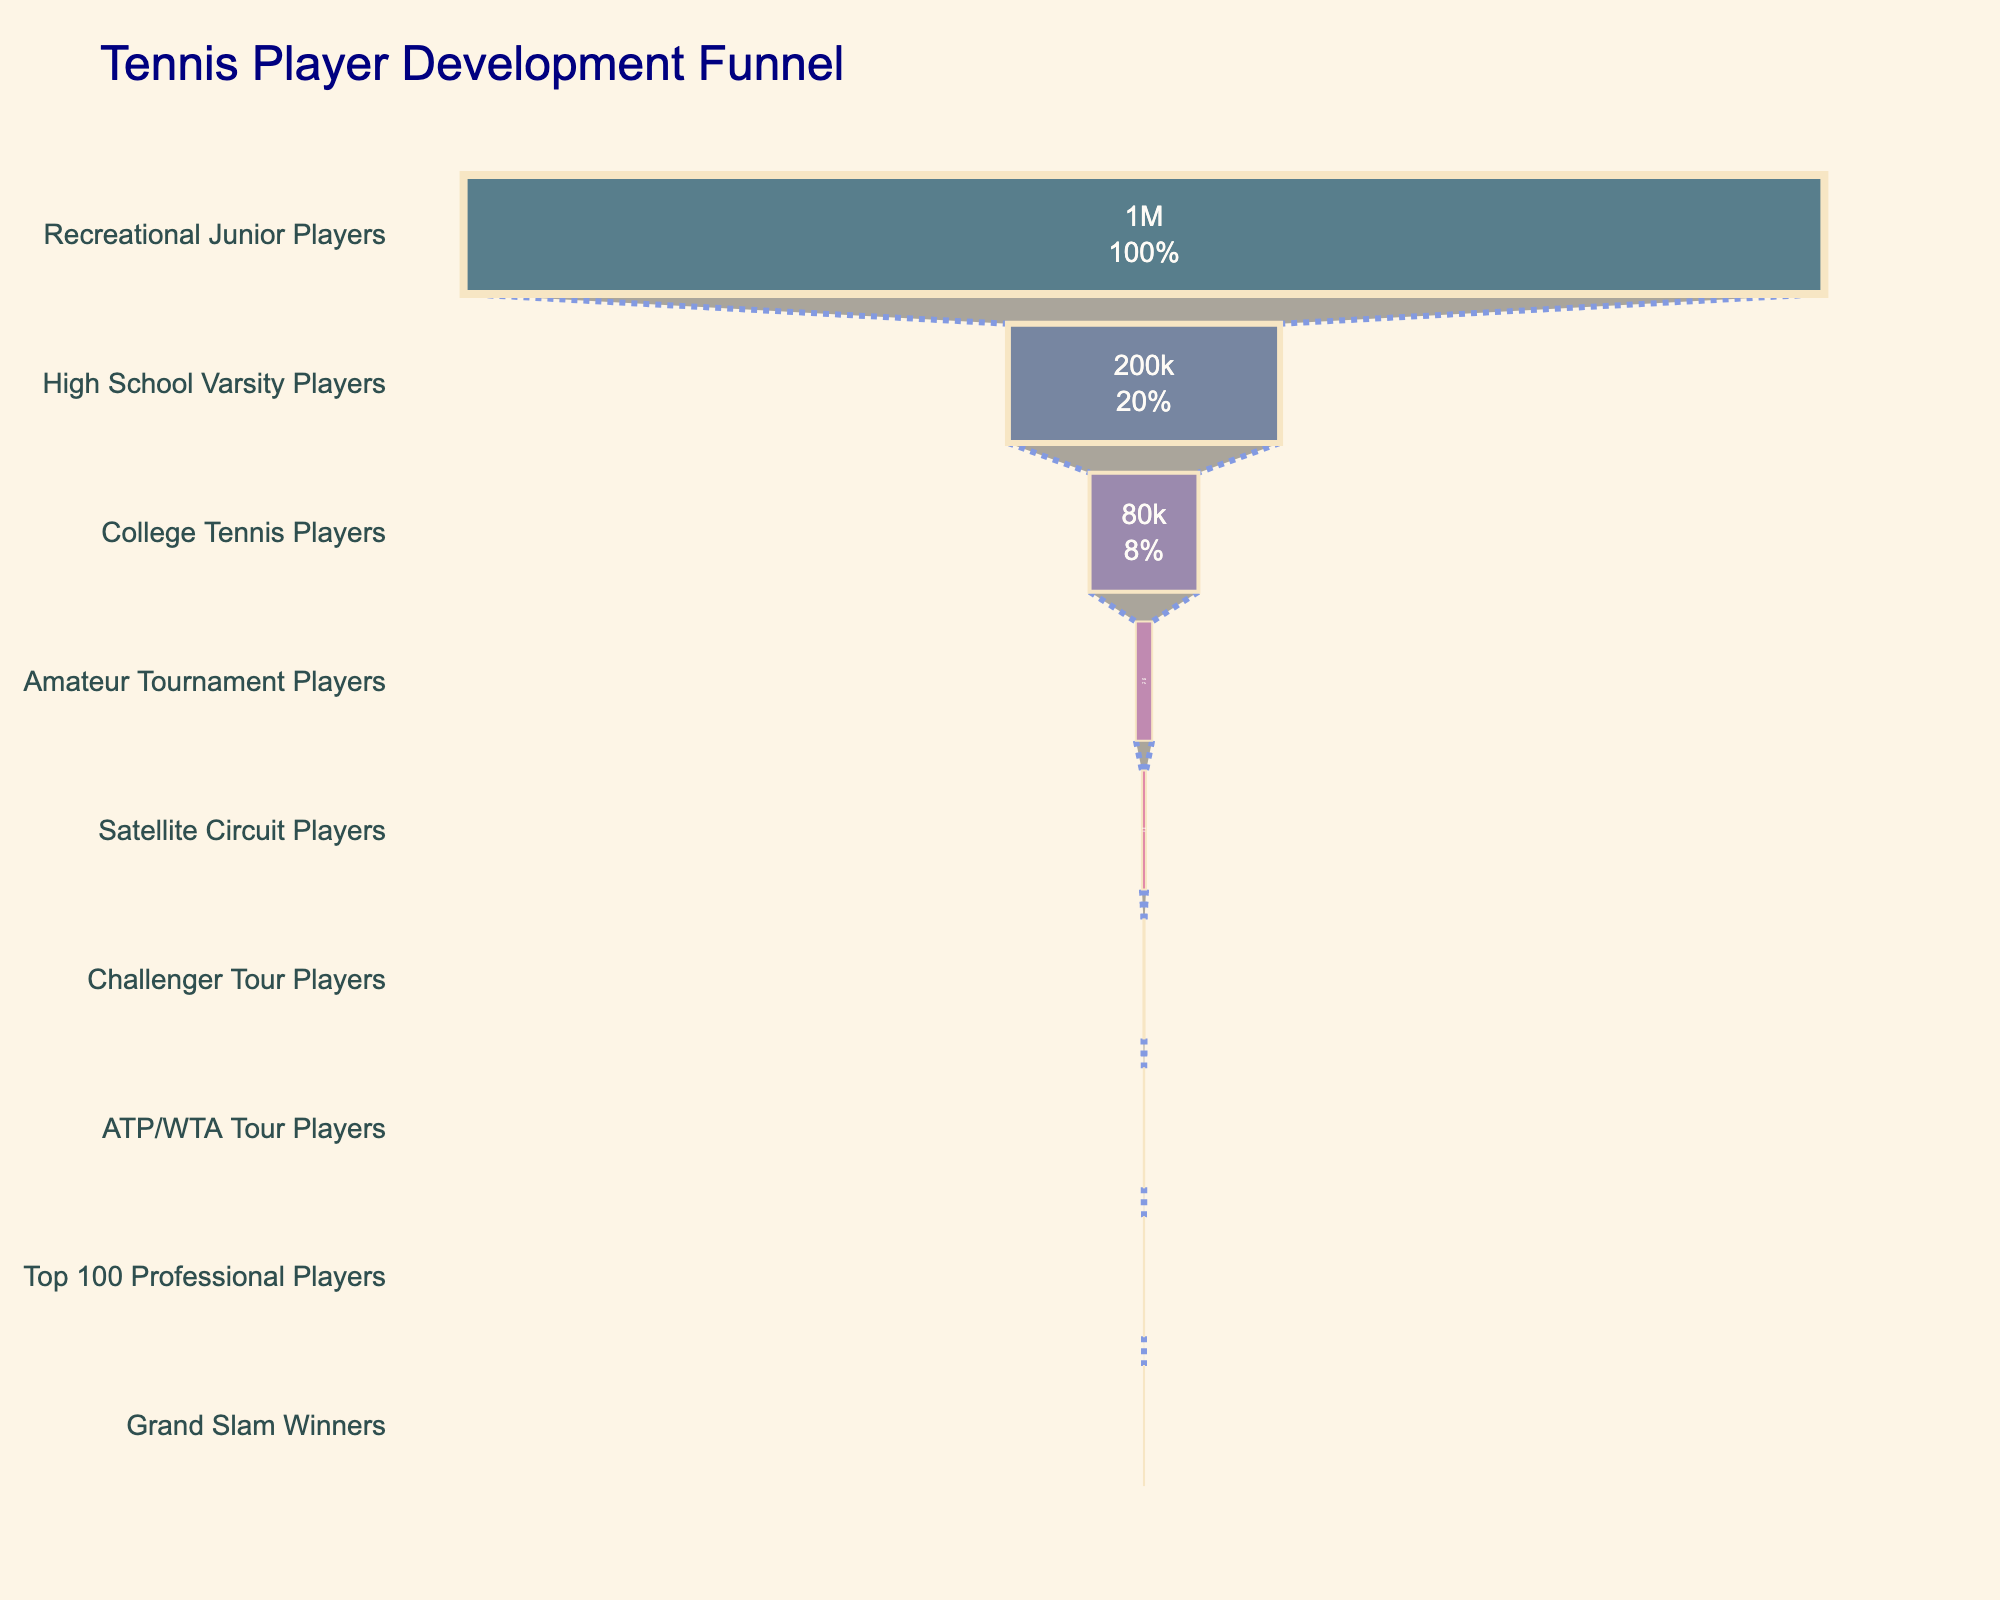What is the title of the funnel chart? The title is generally at the top of the funnel chart and provides an overview of the data being visualized. In this case, it states "Tennis Player Development Funnel."
Answer: Tennis Player Development Funnel How many players start as Recreational Junior Players? Look at the first row of the funnel where the number of players for Recreational Junior Players is stated.
Answer: 1,000,000 Which stage has the highest attrition rate? The attrition rate is given for each stage. The highest percentage indicates the highest attrition. The Recreational Junior Players stage has an attrition rate of 80%.
Answer: Recreational Junior Players What is the percentage decrease in players from High School Varsity Players to College Tennis Players? Compare the number of players at the two stages: High School (200,000) and College (80,000). Calculate the percentage decrease: [(200,000 - 80,000)/200,000] * 100.
Answer: 60% How many players remain at the ATP/WTA Tour Players stage? Look for the number of players at the ATP/WTA Tour Players stage in the funnel chart.
Answer: 300 What is the difference in attrition rates between College Tennis Players and Amateur Tournament Players? Find the attrition rates for both stages (85% for College, 75% for Amateur) and subtract the two percentages.
Answer: 10% Is the reduction in players from Challenger Tour Players to Top 100 Professional Players more or less than 50%? Compare the number of players at the two stages (900 at Challenger and 150 at Top 100). Calculate the percentage reduction: [(900 - 150)/900] * 100 = 83.3%.
Answer: More List the stages where the attrition rate is above 70%. Identify all stages where the given attrition rate is greater than 70%. These are Recreational Junior Players (80%), College Tennis Players (85%), Amateur Tournament Players (75%), and Satellite Circuit Players (70%).
Answer: Recreational Junior Players, College Tennis Players, Amateur Tournament Players, Satellite Circuit Players How many stages are depicted in the funnel chart? Count the total number of distinct stages listed down the funnel chart.
Answer: 9 